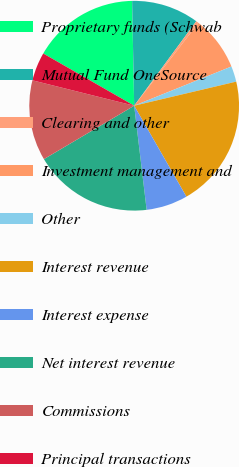Convert chart to OTSL. <chart><loc_0><loc_0><loc_500><loc_500><pie_chart><fcel>Proprietary funds (Schwab<fcel>Mutual Fund OneSource <fcel>Clearing and other<fcel>Investment management and<fcel>Other<fcel>Interest revenue<fcel>Interest expense<fcel>Net interest revenue<fcel>Commissions<fcel>Principal transactions<nl><fcel>16.39%<fcel>10.4%<fcel>0.41%<fcel>8.4%<fcel>2.41%<fcel>20.39%<fcel>6.4%<fcel>18.39%<fcel>12.4%<fcel>4.4%<nl></chart> 